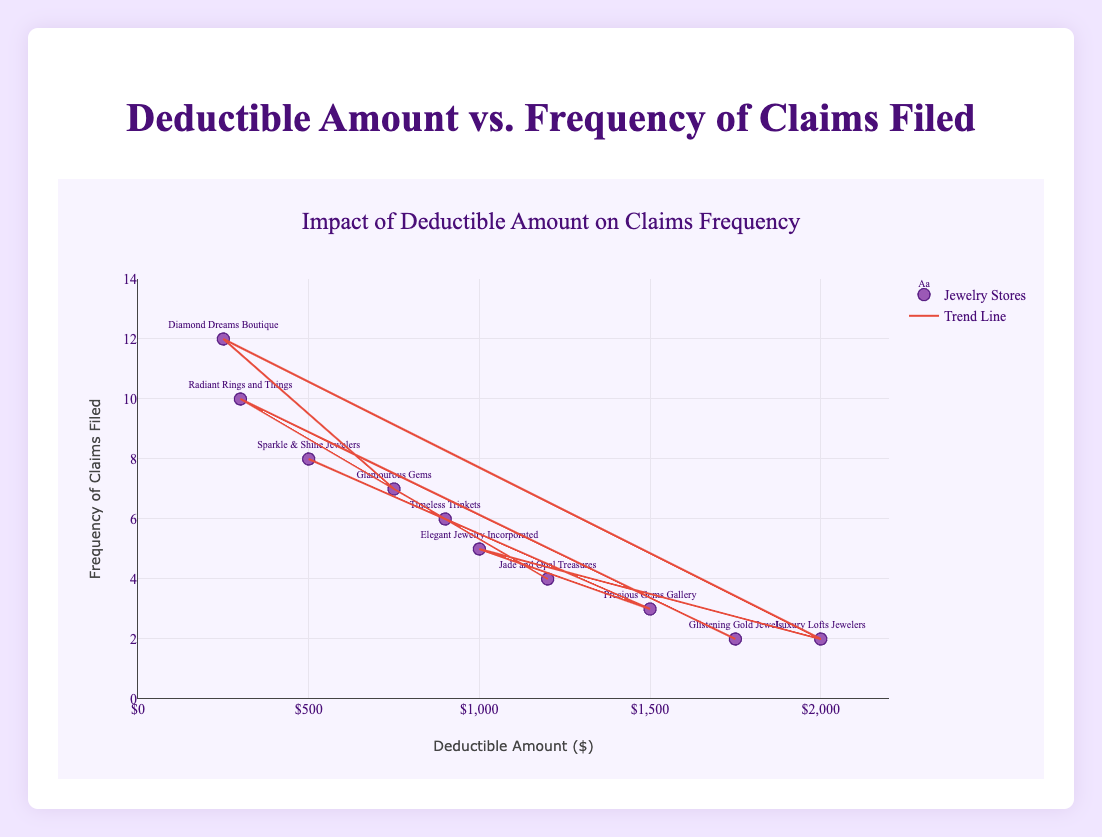What is the title of the figure? The title is located at the top of the figure, displaying in large, bold text. It provides a summary of what the figure represents.
Answer: Deductible Amount vs. Frequency of Claims Filed What are the labels on the x-axis and y-axis? The labels of the axes are typically placed near the respective axes for identification. They indicate what the axes represent in the data.
Answer: x-axis: Deductible Amount ($), y-axis: Frequency of Claims Filed Which jewelry store has the highest frequency of claims filed? To determine this, look for the data point that is highest along the y-axis. Reviewing the labels reveals which jewelry store corresponds to this point.
Answer: Diamond Dreams Boutique How many jewelry stores have filed more than 5 claims? Identify the data points above 5 on the y-axis. Count these data points, then refer to the labels to ensure the correct count.
Answer: 4 Which jewelry store has the lowest deductible amount and what is its frequency of claims filed? Find the data point farthest to the left along the x-axis and observe its y-axis value. The text label will indicate which jewelry store this is.
Answer: Diamond Dreams Boutique, 12 Is there a general trend between deductible amount and frequency of claims filed? Refer to the trend line added to the scatter plot. The slope of this line indicates the overall direction of the relationship between the variables.
Answer: Negative trend Comparing Sparkle & Shine Jewelers and Precious Gems Gallery, which has a higher deductible amount and by how much? Locate both stores on the graph. Sparkle & Shine Jewelers is at $500, and Precious Gems Gallery is at $1500. Calculate the difference between these two amounts.
Answer: Precious Gems Gallery by $1000 What is the range of deductible amounts represented in this figure? Identify the smallest and largest deductible amounts on the x-axis. Subtract the smallest from the largest to find the range.
Answer: $250 to $2000 Do any two jewelry stores have the same frequency of claims filed? Look for data points that are at the same level on the y-axis. Check the text labels of these points to verify if they belong to different jewelry stores.
Answer: Yes, Luxury Lofts Jewelers and Glistening Gold Jewels both have 2 claims Which jewelry store has the highest deductible amount and what is its frequency of claims filed? Identify the data point farthest to the right along the x-axis and observe its y-axis value. The text label will indicate the jewelry store.
Answer: Luxury Lofts Jewelers, 2 